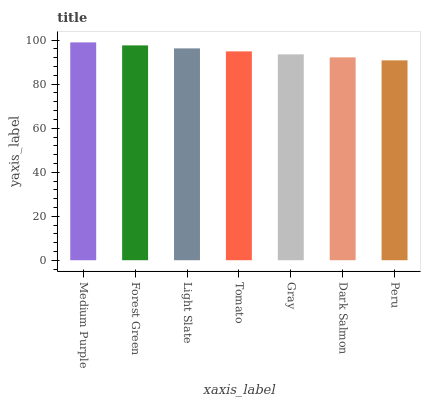Is Forest Green the minimum?
Answer yes or no. No. Is Forest Green the maximum?
Answer yes or no. No. Is Medium Purple greater than Forest Green?
Answer yes or no. Yes. Is Forest Green less than Medium Purple?
Answer yes or no. Yes. Is Forest Green greater than Medium Purple?
Answer yes or no. No. Is Medium Purple less than Forest Green?
Answer yes or no. No. Is Tomato the high median?
Answer yes or no. Yes. Is Tomato the low median?
Answer yes or no. Yes. Is Medium Purple the high median?
Answer yes or no. No. Is Peru the low median?
Answer yes or no. No. 